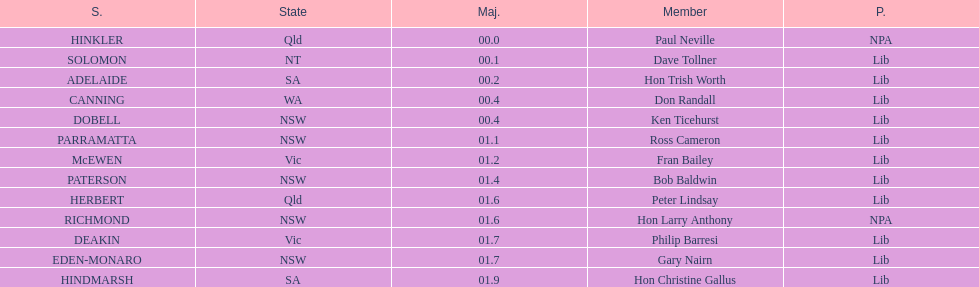What is the total of seats? 13. Would you mind parsing the complete table? {'header': ['S.', 'State', 'Maj.', 'Member', 'P.'], 'rows': [['HINKLER', 'Qld', '00.0', 'Paul Neville', 'NPA'], ['SOLOMON', 'NT', '00.1', 'Dave Tollner', 'Lib'], ['ADELAIDE', 'SA', '00.2', 'Hon Trish Worth', 'Lib'], ['CANNING', 'WA', '00.4', 'Don Randall', 'Lib'], ['DOBELL', 'NSW', '00.4', 'Ken Ticehurst', 'Lib'], ['PARRAMATTA', 'NSW', '01.1', 'Ross Cameron', 'Lib'], ['McEWEN', 'Vic', '01.2', 'Fran Bailey', 'Lib'], ['PATERSON', 'NSW', '01.4', 'Bob Baldwin', 'Lib'], ['HERBERT', 'Qld', '01.6', 'Peter Lindsay', 'Lib'], ['RICHMOND', 'NSW', '01.6', 'Hon Larry Anthony', 'NPA'], ['DEAKIN', 'Vic', '01.7', 'Philip Barresi', 'Lib'], ['EDEN-MONARO', 'NSW', '01.7', 'Gary Nairn', 'Lib'], ['HINDMARSH', 'SA', '01.9', 'Hon Christine Gallus', 'Lib']]} 